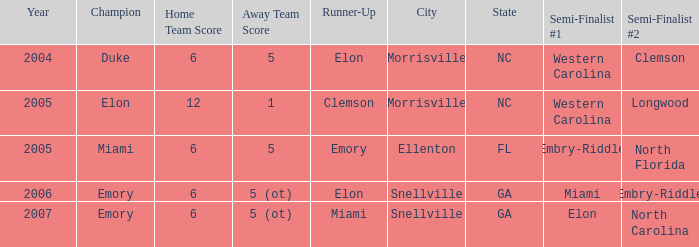When Embry-Riddle made it to the first semi finalist slot, list all the runners up. Emory. 